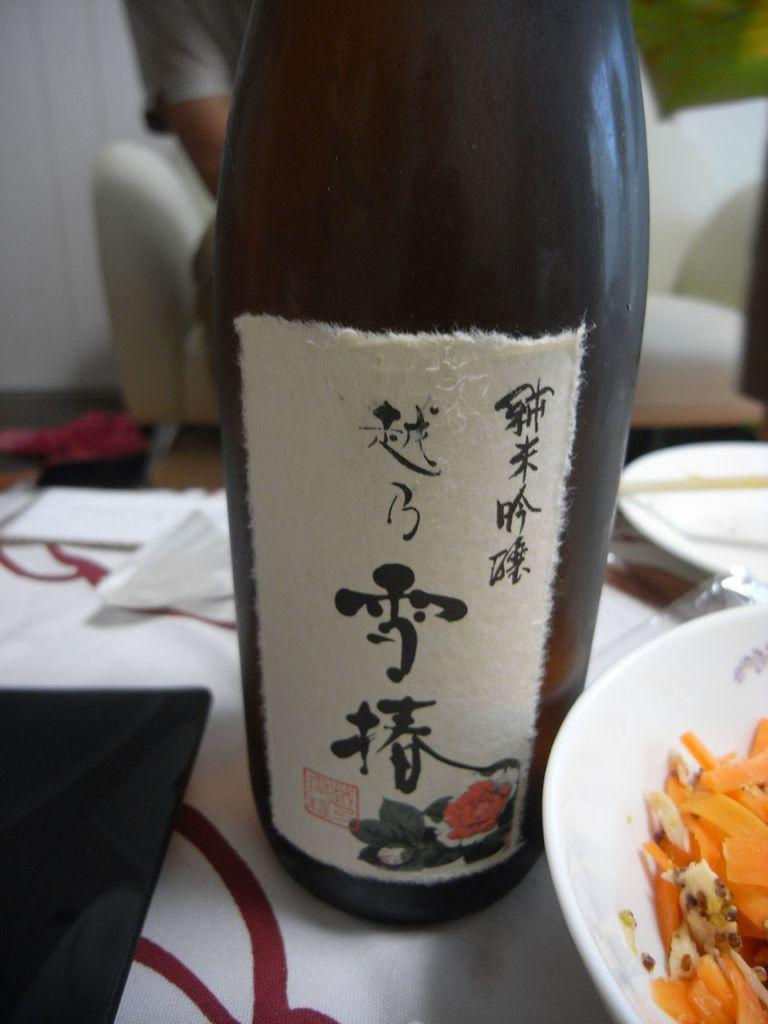What piece of furniture is in the image? There is a table in the image. What is on the table? There are papers, a bottle, and a bowl with food on the table. What is behind the table? There is a sofa behind the table. Who is sitting on the sofa? A person is sitting on the sofa. What type of floor can be seen in the image? There is no information about the floor in the image. What is the person on the sofa feeling towards the person sitting next to them? The image does not provide any information about the person's emotions or feelings towards others. 